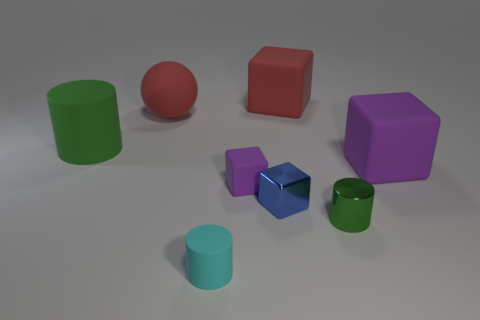Is the number of tiny metallic cubes that are in front of the tiny metallic cylinder greater than the number of cyan rubber cylinders in front of the tiny cyan cylinder?
Give a very brief answer. No. There is a large sphere; is its color the same as the large cube that is in front of the large matte cylinder?
Provide a short and direct response. No. There is another cylinder that is the same size as the green shiny cylinder; what is it made of?
Make the answer very short. Rubber. What number of things are large purple things or rubber things that are to the left of the big purple rubber cube?
Ensure brevity in your answer.  6. Is the size of the blue thing the same as the red rubber object behind the red sphere?
Make the answer very short. No. How many spheres are big green rubber things or small cyan rubber objects?
Give a very brief answer. 0. How many rubber objects are right of the big cylinder and behind the blue metal block?
Provide a short and direct response. 4. How many other objects are the same color as the small matte cube?
Provide a succinct answer. 1. What shape is the purple thing that is in front of the big purple rubber object?
Offer a terse response. Cube. Does the cyan cylinder have the same material as the large red sphere?
Your answer should be compact. Yes. 